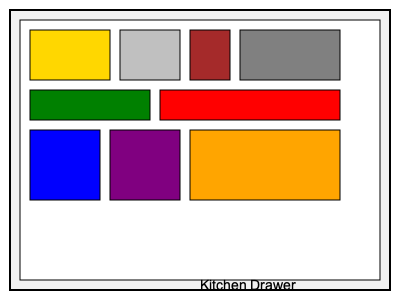In the kitchen drawer shown above, how many different ways can you arrange the 9 utensils to maximize space efficiency, assuming all utensils must be placed flat and cannot overlap? To solve this spatial intelligence puzzle, we need to follow these steps:

1. Identify the utensils:
   - 4 rectangular utensils in the top row
   - 2 long utensils in the second row
   - 3 square utensils in the bottom row

2. Analyze the drawer space:
   The drawer can be divided into a 4x3 grid, with each cell being the size of the smallest square utensil.

3. Consider possible arrangements:
   a) Horizontal arrangement:
      - The 4 rectangular utensils can fit in one row (4 cells)
      - The 2 long utensils can fit in one row (4 cells)
      - The 3 square utensils can fit in one row (3 cells)
   
   b) Vertical arrangement:
      - The 2 long utensils can be placed vertically (3 cells each)
      - The 4 rectangular utensils can be placed in 2 columns (2 cells each)
      - The 3 square utensils can fit in the remaining space

4. Calculate the number of efficient arrangements:
   - The horizontal arrangement has only one possible configuration
   - The vertical arrangement allows for 2 possible configurations:
     1. Long utensils on the sides, rectangles in the middle
     2. Long utensils together on one side, rectangles on the other

Therefore, there are 3 different ways to arrange the utensils efficiently.
Answer: 3 